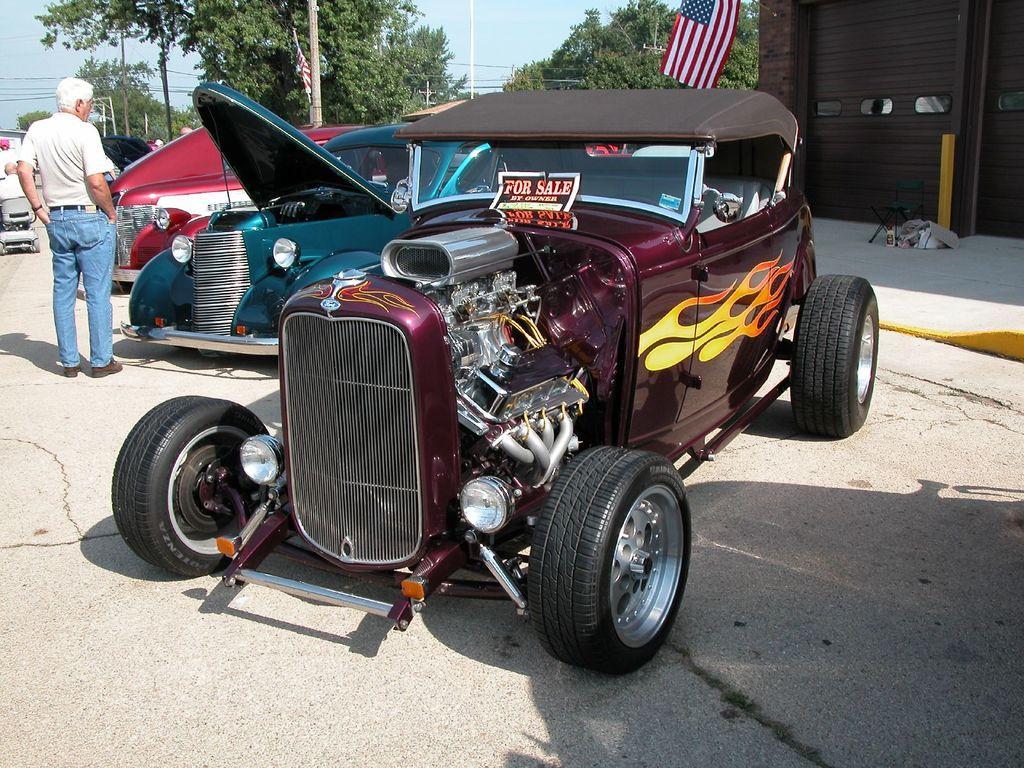Please provide a concise description of this image. In the foreground of the picture there are cars, people, pavement and road. In the background there are trees, poles, flags, cables and building. Sky is sunny. 